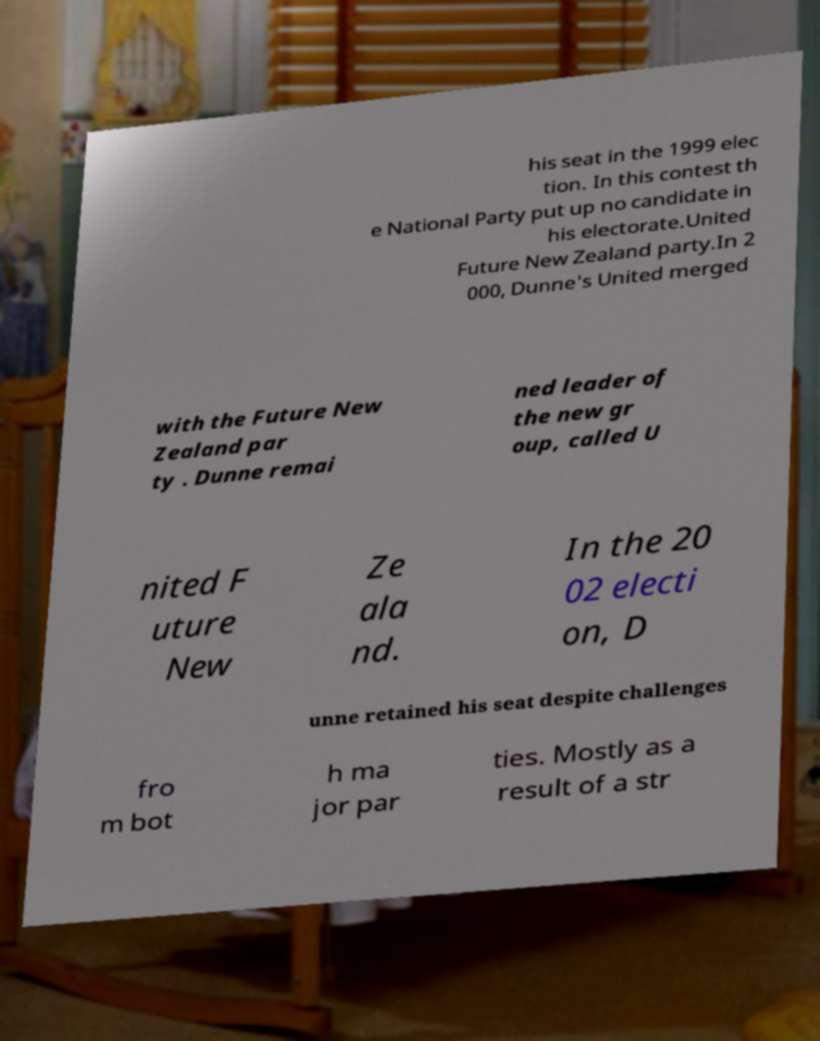Please identify and transcribe the text found in this image. his seat in the 1999 elec tion. In this contest th e National Party put up no candidate in his electorate.United Future New Zealand party.In 2 000, Dunne's United merged with the Future New Zealand par ty . Dunne remai ned leader of the new gr oup, called U nited F uture New Ze ala nd. In the 20 02 electi on, D unne retained his seat despite challenges fro m bot h ma jor par ties. Mostly as a result of a str 